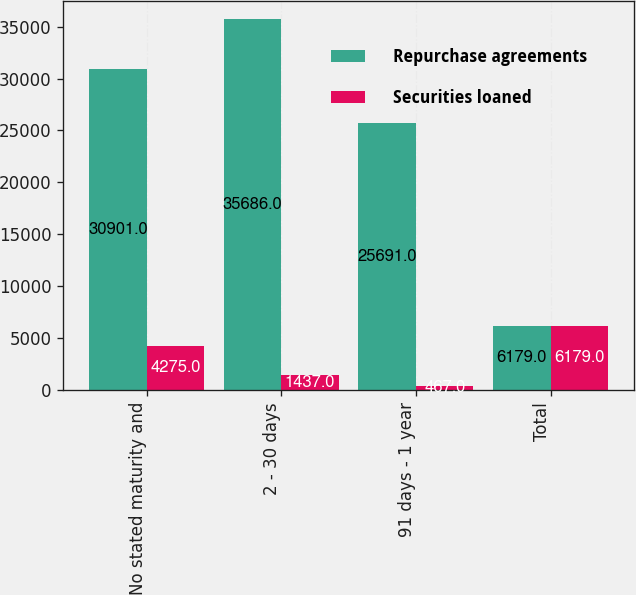<chart> <loc_0><loc_0><loc_500><loc_500><stacked_bar_chart><ecel><fcel>No stated maturity and<fcel>2 - 30 days<fcel>91 days - 1 year<fcel>Total<nl><fcel>Repurchase agreements<fcel>30901<fcel>35686<fcel>25691<fcel>6179<nl><fcel>Securities loaned<fcel>4275<fcel>1437<fcel>467<fcel>6179<nl></chart> 